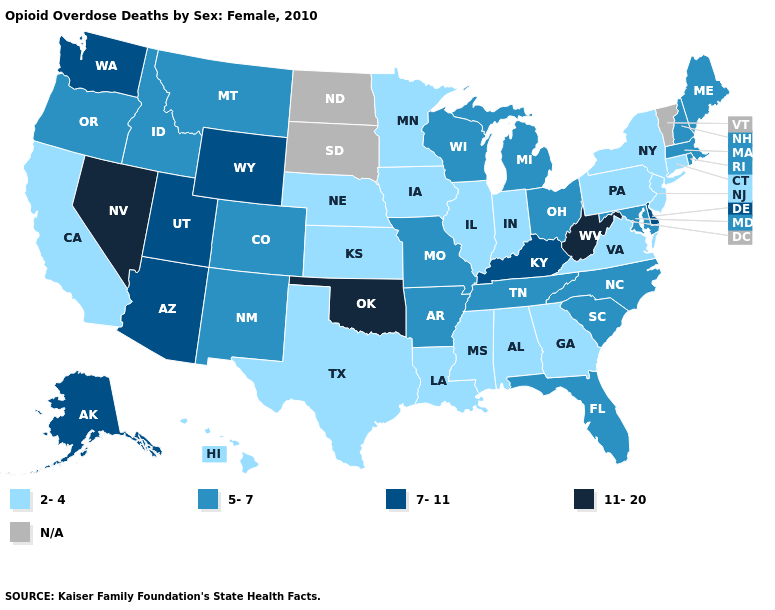What is the value of Massachusetts?
Answer briefly. 5-7. What is the lowest value in the Northeast?
Be succinct. 2-4. What is the value of North Carolina?
Write a very short answer. 5-7. Name the states that have a value in the range N/A?
Short answer required. North Dakota, South Dakota, Vermont. Which states have the lowest value in the South?
Be succinct. Alabama, Georgia, Louisiana, Mississippi, Texas, Virginia. What is the value of Indiana?
Answer briefly. 2-4. Does Georgia have the lowest value in the South?
Answer briefly. Yes. Among the states that border Colorado , which have the lowest value?
Quick response, please. Kansas, Nebraska. What is the value of Alabama?
Give a very brief answer. 2-4. What is the highest value in the West ?
Short answer required. 11-20. Does the first symbol in the legend represent the smallest category?
Short answer required. Yes. 